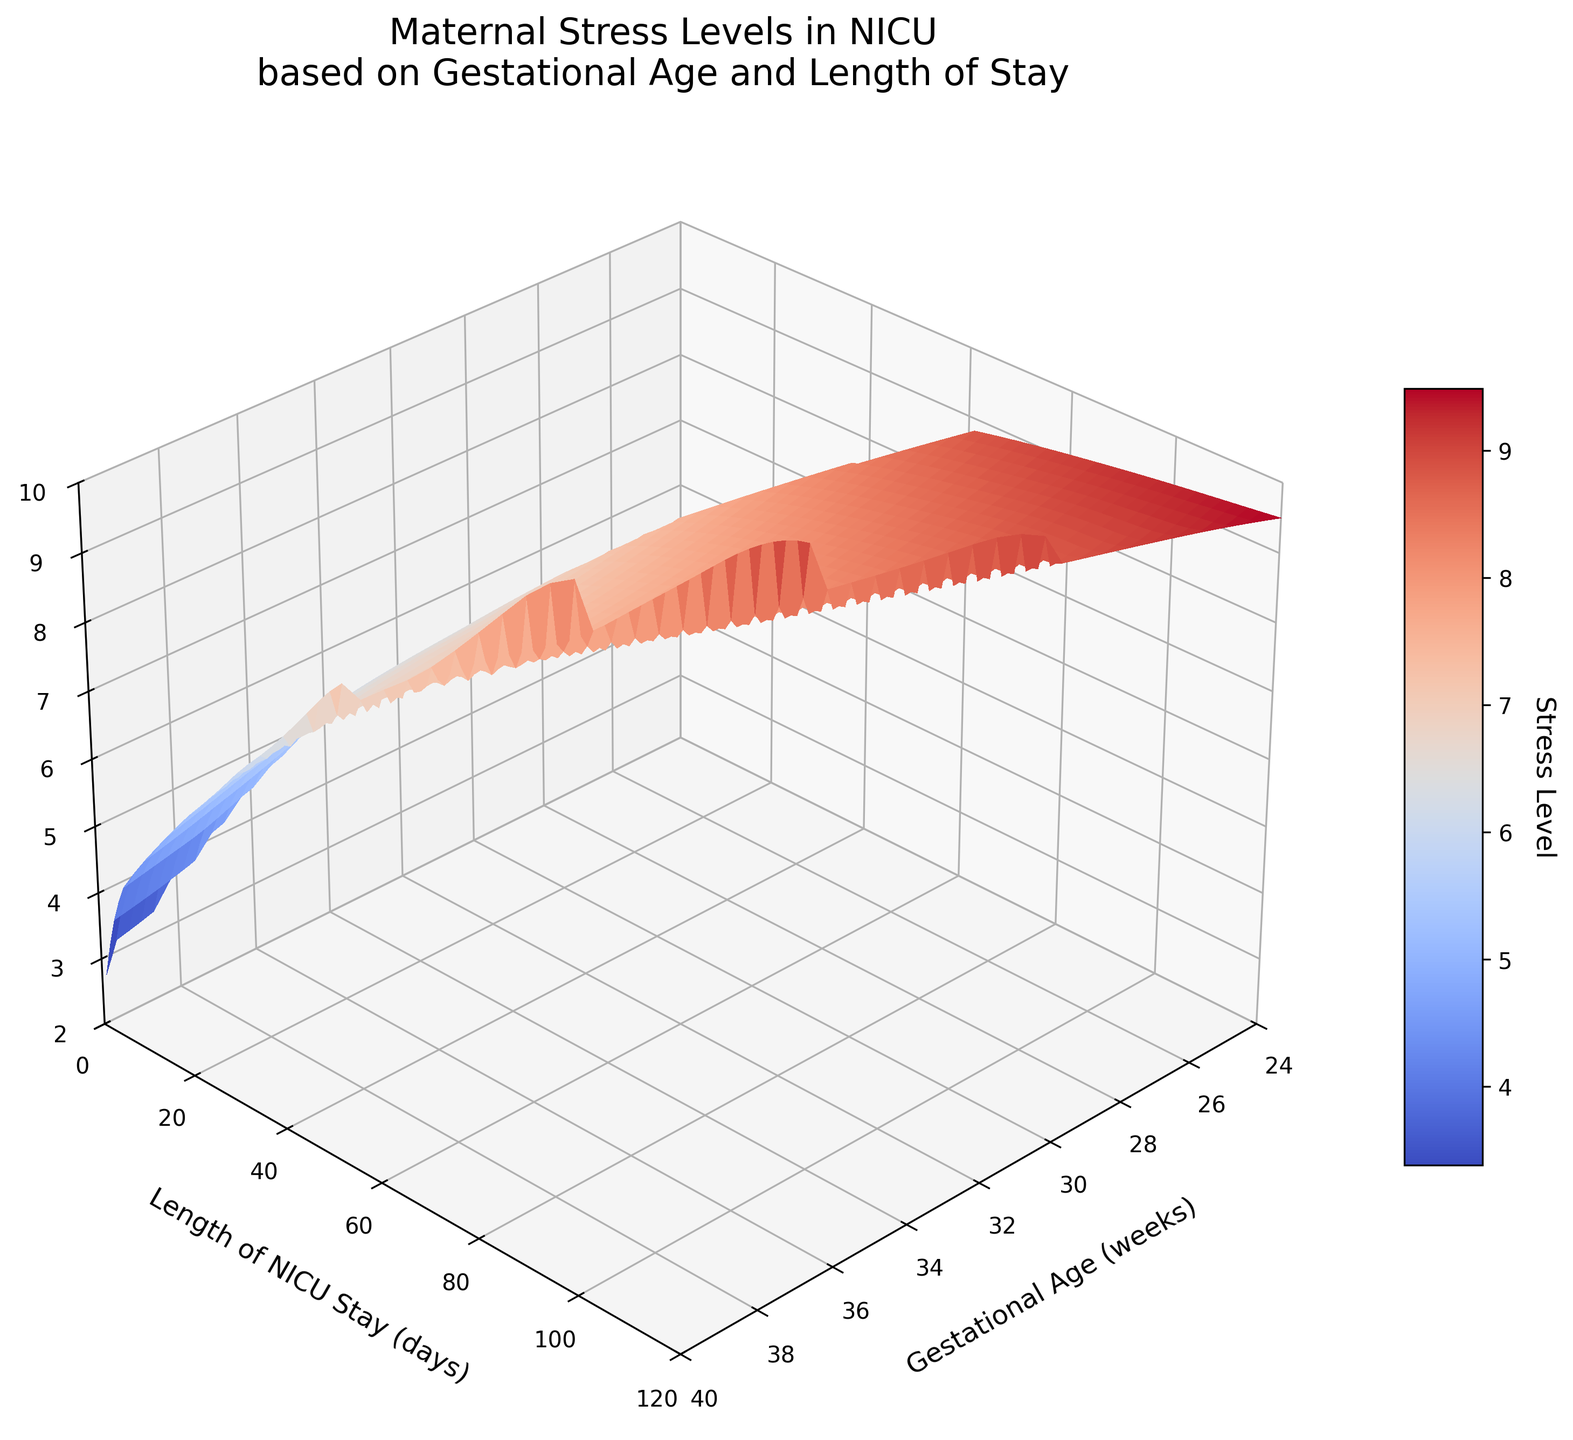What is the title of the plot? The title is displayed at the top of the plot and reads "Maternal Stress Levels in NICU\nbased on Gestational Age and Length of Stay."
Answer: "Maternal Stress Levels in NICU based on Gestational Age and Length of Stay" What are the labels of the axes? The labels of the axes are displayed next to their respective axes. The x-axis is labeled "Gestational Age (weeks)," the y-axis is labeled "Length of NICU Stay (days)," and the z-axis is labeled "Maternal Stress Level (1-10)."
Answer: The x-axis is "Gestational Age (weeks)," the y-axis is "Length of NICU Stay (days)," and the z-axis is "Maternal Stress Level (1-10)" What color gradient is used to represent the stress levels? Observing the surface plot, the color gradient shifts from cool to warm tones, implying a transition from blue to red as stress levels increase.
Answer: Blue to red What is the approximate maternal stress level for an infant with a gestational age of 28 weeks and a NICU stay of 60 days? By tracing the point (28 weeks, 60 days) on the surface and noting its height on the z-axis and color, the stress level appears around 8.2.
Answer: Around 8.2 How does the maternal stress level change as the gestational age increases from 24 to 40 weeks for a constant NICU stay of 30 days? Following the contour at 30 days NICU stay, maternal stress decreases steadily from around 9.5 at 24 weeks to about 4.5 at 40 weeks.
Answer: It decreases steadily At what gestational age and NICU stay length is maternal stress the highest, according to the plot? The highest stress level can be seen by observing the peak on the surface plot, which occurs at around 24 weeks gestational age and a NICU stay of 120 days.
Answer: 24 weeks gestational age and 120 days NICU stay Compare maternal stress levels between 32 and 28 weeks gestational age for NICU stays of 60 days each. Which age shows higher stress, and by how much? The plot shows a stress level of 7.8 for 32 weeks and 8.2 for 28 weeks. Thus, the stress at 28 weeks is higher by 0.4 units.
Answer: 28 weeks, by 0.4 units What general trend can you observe between the length of NICU stay and the maternal stress level for infants with a gestational age of 36 weeks? For infants with a 36-week gestational age, as NICU stay length increases from 7 to 30 days, maternal stress levels increase from around 5.2 to 6.9.
Answer: Stress level increases What surface plot feature indicates regions of rapidly changing stress levels for given gestational ages and NICU stay lengths? Features such as steep gradients or sharp peaks on the surface plot indicate regions where stress levels change rapidly.
Answer: Steep gradients or sharp peaks 